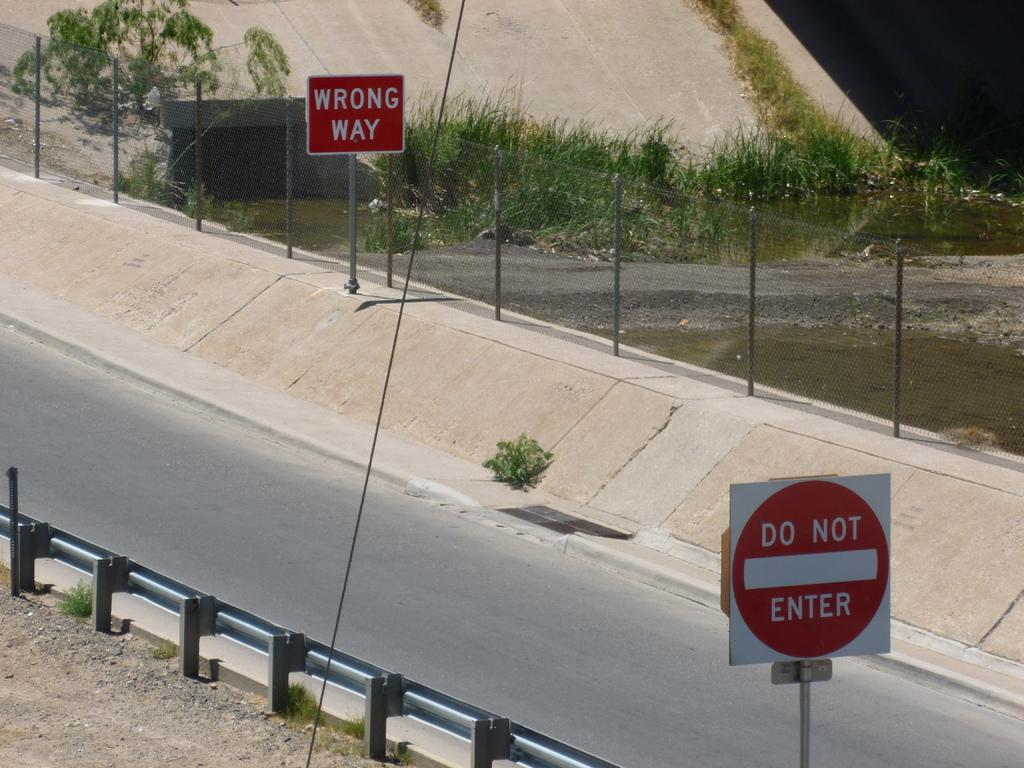<image>
Present a compact description of the photo's key features. Highway with a wrong way sign and do not enter sign 